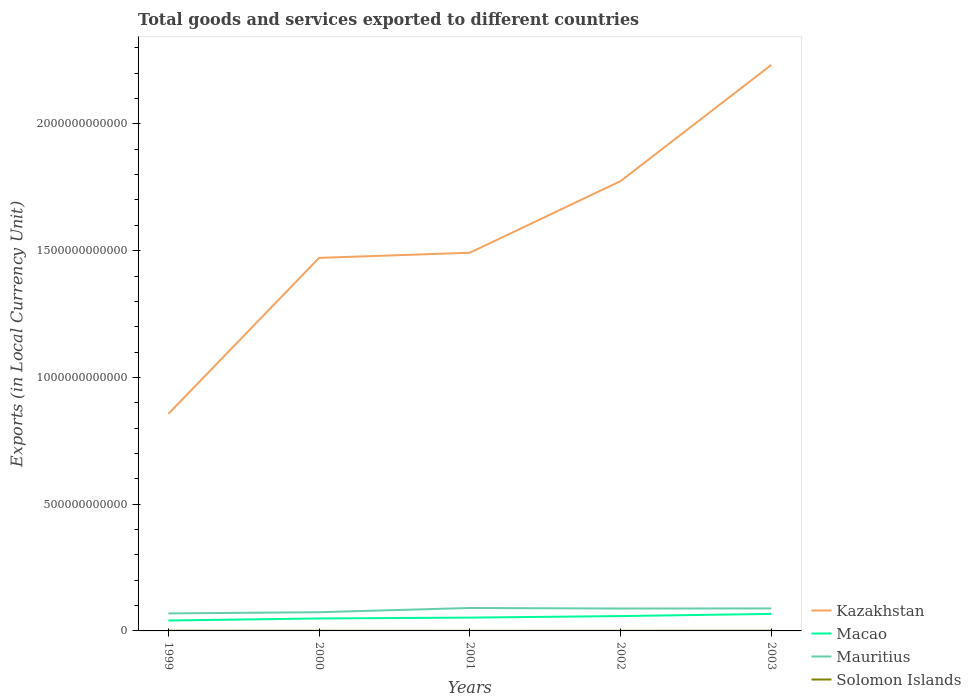How many different coloured lines are there?
Your answer should be compact. 4. Does the line corresponding to Kazakhstan intersect with the line corresponding to Macao?
Keep it short and to the point. No. Across all years, what is the maximum Amount of goods and services exports in Mauritius?
Provide a short and direct response. 6.91e+1. What is the total Amount of goods and services exports in Mauritius in the graph?
Your answer should be compact. -1.66e+1. What is the difference between the highest and the second highest Amount of goods and services exports in Mauritius?
Give a very brief answer. 2.14e+1. Is the Amount of goods and services exports in Kazakhstan strictly greater than the Amount of goods and services exports in Macao over the years?
Provide a succinct answer. No. What is the difference between two consecutive major ticks on the Y-axis?
Your answer should be very brief. 5.00e+11. How many legend labels are there?
Offer a very short reply. 4. How are the legend labels stacked?
Your answer should be very brief. Vertical. What is the title of the graph?
Keep it short and to the point. Total goods and services exported to different countries. Does "French Polynesia" appear as one of the legend labels in the graph?
Your answer should be very brief. No. What is the label or title of the X-axis?
Offer a terse response. Years. What is the label or title of the Y-axis?
Ensure brevity in your answer.  Exports (in Local Currency Unit). What is the Exports (in Local Currency Unit) in Kazakhstan in 1999?
Your answer should be very brief. 8.56e+11. What is the Exports (in Local Currency Unit) in Macao in 1999?
Your response must be concise. 4.11e+1. What is the Exports (in Local Currency Unit) of Mauritius in 1999?
Your answer should be very brief. 6.91e+1. What is the Exports (in Local Currency Unit) in Solomon Islands in 1999?
Give a very brief answer. 8.33e+08. What is the Exports (in Local Currency Unit) in Kazakhstan in 2000?
Offer a terse response. 1.47e+12. What is the Exports (in Local Currency Unit) in Macao in 2000?
Offer a terse response. 4.92e+1. What is the Exports (in Local Currency Unit) in Mauritius in 2000?
Your response must be concise. 7.38e+1. What is the Exports (in Local Currency Unit) in Solomon Islands in 2000?
Make the answer very short. 5.33e+08. What is the Exports (in Local Currency Unit) in Kazakhstan in 2001?
Your answer should be compact. 1.49e+12. What is the Exports (in Local Currency Unit) of Macao in 2001?
Provide a short and direct response. 5.25e+1. What is the Exports (in Local Currency Unit) of Mauritius in 2001?
Give a very brief answer. 9.05e+1. What is the Exports (in Local Currency Unit) in Solomon Islands in 2001?
Make the answer very short. 3.49e+08. What is the Exports (in Local Currency Unit) of Kazakhstan in 2002?
Provide a succinct answer. 1.77e+12. What is the Exports (in Local Currency Unit) in Macao in 2002?
Your response must be concise. 5.86e+1. What is the Exports (in Local Currency Unit) of Mauritius in 2002?
Provide a succinct answer. 8.83e+1. What is the Exports (in Local Currency Unit) of Solomon Islands in 2002?
Provide a short and direct response. 4.63e+08. What is the Exports (in Local Currency Unit) of Kazakhstan in 2003?
Provide a succinct answer. 2.23e+12. What is the Exports (in Local Currency Unit) of Macao in 2003?
Make the answer very short. 6.71e+1. What is the Exports (in Local Currency Unit) of Mauritius in 2003?
Keep it short and to the point. 8.87e+1. What is the Exports (in Local Currency Unit) of Solomon Islands in 2003?
Your response must be concise. 6.60e+08. Across all years, what is the maximum Exports (in Local Currency Unit) in Kazakhstan?
Provide a short and direct response. 2.23e+12. Across all years, what is the maximum Exports (in Local Currency Unit) of Macao?
Give a very brief answer. 6.71e+1. Across all years, what is the maximum Exports (in Local Currency Unit) of Mauritius?
Keep it short and to the point. 9.05e+1. Across all years, what is the maximum Exports (in Local Currency Unit) of Solomon Islands?
Make the answer very short. 8.33e+08. Across all years, what is the minimum Exports (in Local Currency Unit) in Kazakhstan?
Give a very brief answer. 8.56e+11. Across all years, what is the minimum Exports (in Local Currency Unit) in Macao?
Offer a very short reply. 4.11e+1. Across all years, what is the minimum Exports (in Local Currency Unit) in Mauritius?
Keep it short and to the point. 6.91e+1. Across all years, what is the minimum Exports (in Local Currency Unit) of Solomon Islands?
Ensure brevity in your answer.  3.49e+08. What is the total Exports (in Local Currency Unit) in Kazakhstan in the graph?
Provide a succinct answer. 7.83e+12. What is the total Exports (in Local Currency Unit) in Macao in the graph?
Keep it short and to the point. 2.69e+11. What is the total Exports (in Local Currency Unit) in Mauritius in the graph?
Offer a terse response. 4.10e+11. What is the total Exports (in Local Currency Unit) in Solomon Islands in the graph?
Your response must be concise. 2.84e+09. What is the difference between the Exports (in Local Currency Unit) in Kazakhstan in 1999 and that in 2000?
Ensure brevity in your answer.  -6.15e+11. What is the difference between the Exports (in Local Currency Unit) of Macao in 1999 and that in 2000?
Keep it short and to the point. -8.06e+09. What is the difference between the Exports (in Local Currency Unit) of Mauritius in 1999 and that in 2000?
Give a very brief answer. -4.74e+09. What is the difference between the Exports (in Local Currency Unit) of Solomon Islands in 1999 and that in 2000?
Ensure brevity in your answer.  2.99e+08. What is the difference between the Exports (in Local Currency Unit) of Kazakhstan in 1999 and that in 2001?
Offer a terse response. -6.36e+11. What is the difference between the Exports (in Local Currency Unit) in Macao in 1999 and that in 2001?
Give a very brief answer. -1.14e+1. What is the difference between the Exports (in Local Currency Unit) in Mauritius in 1999 and that in 2001?
Your response must be concise. -2.14e+1. What is the difference between the Exports (in Local Currency Unit) in Solomon Islands in 1999 and that in 2001?
Provide a short and direct response. 4.84e+08. What is the difference between the Exports (in Local Currency Unit) of Kazakhstan in 1999 and that in 2002?
Give a very brief answer. -9.18e+11. What is the difference between the Exports (in Local Currency Unit) of Macao in 1999 and that in 2002?
Ensure brevity in your answer.  -1.75e+1. What is the difference between the Exports (in Local Currency Unit) of Mauritius in 1999 and that in 2002?
Provide a short and direct response. -1.92e+1. What is the difference between the Exports (in Local Currency Unit) in Solomon Islands in 1999 and that in 2002?
Your answer should be compact. 3.70e+08. What is the difference between the Exports (in Local Currency Unit) in Kazakhstan in 1999 and that in 2003?
Make the answer very short. -1.38e+12. What is the difference between the Exports (in Local Currency Unit) in Macao in 1999 and that in 2003?
Ensure brevity in your answer.  -2.60e+1. What is the difference between the Exports (in Local Currency Unit) in Mauritius in 1999 and that in 2003?
Provide a succinct answer. -1.96e+1. What is the difference between the Exports (in Local Currency Unit) of Solomon Islands in 1999 and that in 2003?
Give a very brief answer. 1.73e+08. What is the difference between the Exports (in Local Currency Unit) in Kazakhstan in 2000 and that in 2001?
Give a very brief answer. -2.03e+1. What is the difference between the Exports (in Local Currency Unit) of Macao in 2000 and that in 2001?
Offer a very short reply. -3.31e+09. What is the difference between the Exports (in Local Currency Unit) of Mauritius in 2000 and that in 2001?
Your answer should be very brief. -1.66e+1. What is the difference between the Exports (in Local Currency Unit) in Solomon Islands in 2000 and that in 2001?
Make the answer very short. 1.84e+08. What is the difference between the Exports (in Local Currency Unit) in Kazakhstan in 2000 and that in 2002?
Your response must be concise. -3.03e+11. What is the difference between the Exports (in Local Currency Unit) in Macao in 2000 and that in 2002?
Give a very brief answer. -9.45e+09. What is the difference between the Exports (in Local Currency Unit) in Mauritius in 2000 and that in 2002?
Ensure brevity in your answer.  -1.45e+1. What is the difference between the Exports (in Local Currency Unit) in Solomon Islands in 2000 and that in 2002?
Keep it short and to the point. 7.07e+07. What is the difference between the Exports (in Local Currency Unit) of Kazakhstan in 2000 and that in 2003?
Offer a very short reply. -7.61e+11. What is the difference between the Exports (in Local Currency Unit) of Macao in 2000 and that in 2003?
Ensure brevity in your answer.  -1.79e+1. What is the difference between the Exports (in Local Currency Unit) of Mauritius in 2000 and that in 2003?
Make the answer very short. -1.49e+1. What is the difference between the Exports (in Local Currency Unit) of Solomon Islands in 2000 and that in 2003?
Make the answer very short. -1.26e+08. What is the difference between the Exports (in Local Currency Unit) of Kazakhstan in 2001 and that in 2002?
Offer a terse response. -2.83e+11. What is the difference between the Exports (in Local Currency Unit) of Macao in 2001 and that in 2002?
Offer a very short reply. -6.15e+09. What is the difference between the Exports (in Local Currency Unit) of Mauritius in 2001 and that in 2002?
Keep it short and to the point. 2.16e+09. What is the difference between the Exports (in Local Currency Unit) in Solomon Islands in 2001 and that in 2002?
Make the answer very short. -1.14e+08. What is the difference between the Exports (in Local Currency Unit) in Kazakhstan in 2001 and that in 2003?
Your answer should be compact. -7.41e+11. What is the difference between the Exports (in Local Currency Unit) of Macao in 2001 and that in 2003?
Offer a very short reply. -1.46e+1. What is the difference between the Exports (in Local Currency Unit) in Mauritius in 2001 and that in 2003?
Your answer should be compact. 1.75e+09. What is the difference between the Exports (in Local Currency Unit) in Solomon Islands in 2001 and that in 2003?
Offer a terse response. -3.10e+08. What is the difference between the Exports (in Local Currency Unit) in Kazakhstan in 2002 and that in 2003?
Your answer should be compact. -4.58e+11. What is the difference between the Exports (in Local Currency Unit) of Macao in 2002 and that in 2003?
Offer a terse response. -8.47e+09. What is the difference between the Exports (in Local Currency Unit) of Mauritius in 2002 and that in 2003?
Your answer should be very brief. -4.13e+08. What is the difference between the Exports (in Local Currency Unit) in Solomon Islands in 2002 and that in 2003?
Your response must be concise. -1.97e+08. What is the difference between the Exports (in Local Currency Unit) of Kazakhstan in 1999 and the Exports (in Local Currency Unit) of Macao in 2000?
Provide a short and direct response. 8.07e+11. What is the difference between the Exports (in Local Currency Unit) of Kazakhstan in 1999 and the Exports (in Local Currency Unit) of Mauritius in 2000?
Provide a succinct answer. 7.82e+11. What is the difference between the Exports (in Local Currency Unit) of Kazakhstan in 1999 and the Exports (in Local Currency Unit) of Solomon Islands in 2000?
Your answer should be very brief. 8.56e+11. What is the difference between the Exports (in Local Currency Unit) of Macao in 1999 and the Exports (in Local Currency Unit) of Mauritius in 2000?
Offer a terse response. -3.27e+1. What is the difference between the Exports (in Local Currency Unit) in Macao in 1999 and the Exports (in Local Currency Unit) in Solomon Islands in 2000?
Your answer should be very brief. 4.06e+1. What is the difference between the Exports (in Local Currency Unit) in Mauritius in 1999 and the Exports (in Local Currency Unit) in Solomon Islands in 2000?
Your response must be concise. 6.86e+1. What is the difference between the Exports (in Local Currency Unit) in Kazakhstan in 1999 and the Exports (in Local Currency Unit) in Macao in 2001?
Your answer should be very brief. 8.04e+11. What is the difference between the Exports (in Local Currency Unit) of Kazakhstan in 1999 and the Exports (in Local Currency Unit) of Mauritius in 2001?
Your answer should be very brief. 7.66e+11. What is the difference between the Exports (in Local Currency Unit) of Kazakhstan in 1999 and the Exports (in Local Currency Unit) of Solomon Islands in 2001?
Provide a succinct answer. 8.56e+11. What is the difference between the Exports (in Local Currency Unit) of Macao in 1999 and the Exports (in Local Currency Unit) of Mauritius in 2001?
Offer a terse response. -4.93e+1. What is the difference between the Exports (in Local Currency Unit) in Macao in 1999 and the Exports (in Local Currency Unit) in Solomon Islands in 2001?
Your answer should be compact. 4.08e+1. What is the difference between the Exports (in Local Currency Unit) of Mauritius in 1999 and the Exports (in Local Currency Unit) of Solomon Islands in 2001?
Give a very brief answer. 6.88e+1. What is the difference between the Exports (in Local Currency Unit) of Kazakhstan in 1999 and the Exports (in Local Currency Unit) of Macao in 2002?
Give a very brief answer. 7.98e+11. What is the difference between the Exports (in Local Currency Unit) in Kazakhstan in 1999 and the Exports (in Local Currency Unit) in Mauritius in 2002?
Your answer should be very brief. 7.68e+11. What is the difference between the Exports (in Local Currency Unit) in Kazakhstan in 1999 and the Exports (in Local Currency Unit) in Solomon Islands in 2002?
Provide a succinct answer. 8.56e+11. What is the difference between the Exports (in Local Currency Unit) in Macao in 1999 and the Exports (in Local Currency Unit) in Mauritius in 2002?
Offer a terse response. -4.72e+1. What is the difference between the Exports (in Local Currency Unit) of Macao in 1999 and the Exports (in Local Currency Unit) of Solomon Islands in 2002?
Your response must be concise. 4.07e+1. What is the difference between the Exports (in Local Currency Unit) of Mauritius in 1999 and the Exports (in Local Currency Unit) of Solomon Islands in 2002?
Keep it short and to the point. 6.86e+1. What is the difference between the Exports (in Local Currency Unit) in Kazakhstan in 1999 and the Exports (in Local Currency Unit) in Macao in 2003?
Give a very brief answer. 7.89e+11. What is the difference between the Exports (in Local Currency Unit) of Kazakhstan in 1999 and the Exports (in Local Currency Unit) of Mauritius in 2003?
Make the answer very short. 7.68e+11. What is the difference between the Exports (in Local Currency Unit) of Kazakhstan in 1999 and the Exports (in Local Currency Unit) of Solomon Islands in 2003?
Keep it short and to the point. 8.56e+11. What is the difference between the Exports (in Local Currency Unit) of Macao in 1999 and the Exports (in Local Currency Unit) of Mauritius in 2003?
Provide a short and direct response. -4.76e+1. What is the difference between the Exports (in Local Currency Unit) in Macao in 1999 and the Exports (in Local Currency Unit) in Solomon Islands in 2003?
Provide a short and direct response. 4.05e+1. What is the difference between the Exports (in Local Currency Unit) of Mauritius in 1999 and the Exports (in Local Currency Unit) of Solomon Islands in 2003?
Make the answer very short. 6.84e+1. What is the difference between the Exports (in Local Currency Unit) in Kazakhstan in 2000 and the Exports (in Local Currency Unit) in Macao in 2001?
Offer a terse response. 1.42e+12. What is the difference between the Exports (in Local Currency Unit) in Kazakhstan in 2000 and the Exports (in Local Currency Unit) in Mauritius in 2001?
Make the answer very short. 1.38e+12. What is the difference between the Exports (in Local Currency Unit) of Kazakhstan in 2000 and the Exports (in Local Currency Unit) of Solomon Islands in 2001?
Provide a short and direct response. 1.47e+12. What is the difference between the Exports (in Local Currency Unit) in Macao in 2000 and the Exports (in Local Currency Unit) in Mauritius in 2001?
Provide a succinct answer. -4.13e+1. What is the difference between the Exports (in Local Currency Unit) in Macao in 2000 and the Exports (in Local Currency Unit) in Solomon Islands in 2001?
Make the answer very short. 4.88e+1. What is the difference between the Exports (in Local Currency Unit) of Mauritius in 2000 and the Exports (in Local Currency Unit) of Solomon Islands in 2001?
Offer a terse response. 7.35e+1. What is the difference between the Exports (in Local Currency Unit) of Kazakhstan in 2000 and the Exports (in Local Currency Unit) of Macao in 2002?
Keep it short and to the point. 1.41e+12. What is the difference between the Exports (in Local Currency Unit) in Kazakhstan in 2000 and the Exports (in Local Currency Unit) in Mauritius in 2002?
Your answer should be compact. 1.38e+12. What is the difference between the Exports (in Local Currency Unit) of Kazakhstan in 2000 and the Exports (in Local Currency Unit) of Solomon Islands in 2002?
Your answer should be very brief. 1.47e+12. What is the difference between the Exports (in Local Currency Unit) in Macao in 2000 and the Exports (in Local Currency Unit) in Mauritius in 2002?
Ensure brevity in your answer.  -3.91e+1. What is the difference between the Exports (in Local Currency Unit) of Macao in 2000 and the Exports (in Local Currency Unit) of Solomon Islands in 2002?
Keep it short and to the point. 4.87e+1. What is the difference between the Exports (in Local Currency Unit) of Mauritius in 2000 and the Exports (in Local Currency Unit) of Solomon Islands in 2002?
Ensure brevity in your answer.  7.34e+1. What is the difference between the Exports (in Local Currency Unit) in Kazakhstan in 2000 and the Exports (in Local Currency Unit) in Macao in 2003?
Provide a short and direct response. 1.40e+12. What is the difference between the Exports (in Local Currency Unit) of Kazakhstan in 2000 and the Exports (in Local Currency Unit) of Mauritius in 2003?
Offer a terse response. 1.38e+12. What is the difference between the Exports (in Local Currency Unit) of Kazakhstan in 2000 and the Exports (in Local Currency Unit) of Solomon Islands in 2003?
Your answer should be compact. 1.47e+12. What is the difference between the Exports (in Local Currency Unit) in Macao in 2000 and the Exports (in Local Currency Unit) in Mauritius in 2003?
Your response must be concise. -3.95e+1. What is the difference between the Exports (in Local Currency Unit) in Macao in 2000 and the Exports (in Local Currency Unit) in Solomon Islands in 2003?
Make the answer very short. 4.85e+1. What is the difference between the Exports (in Local Currency Unit) of Mauritius in 2000 and the Exports (in Local Currency Unit) of Solomon Islands in 2003?
Offer a terse response. 7.32e+1. What is the difference between the Exports (in Local Currency Unit) in Kazakhstan in 2001 and the Exports (in Local Currency Unit) in Macao in 2002?
Give a very brief answer. 1.43e+12. What is the difference between the Exports (in Local Currency Unit) in Kazakhstan in 2001 and the Exports (in Local Currency Unit) in Mauritius in 2002?
Offer a terse response. 1.40e+12. What is the difference between the Exports (in Local Currency Unit) of Kazakhstan in 2001 and the Exports (in Local Currency Unit) of Solomon Islands in 2002?
Your answer should be very brief. 1.49e+12. What is the difference between the Exports (in Local Currency Unit) in Macao in 2001 and the Exports (in Local Currency Unit) in Mauritius in 2002?
Your answer should be compact. -3.58e+1. What is the difference between the Exports (in Local Currency Unit) of Macao in 2001 and the Exports (in Local Currency Unit) of Solomon Islands in 2002?
Ensure brevity in your answer.  5.20e+1. What is the difference between the Exports (in Local Currency Unit) in Mauritius in 2001 and the Exports (in Local Currency Unit) in Solomon Islands in 2002?
Your response must be concise. 9.00e+1. What is the difference between the Exports (in Local Currency Unit) in Kazakhstan in 2001 and the Exports (in Local Currency Unit) in Macao in 2003?
Offer a terse response. 1.42e+12. What is the difference between the Exports (in Local Currency Unit) in Kazakhstan in 2001 and the Exports (in Local Currency Unit) in Mauritius in 2003?
Keep it short and to the point. 1.40e+12. What is the difference between the Exports (in Local Currency Unit) in Kazakhstan in 2001 and the Exports (in Local Currency Unit) in Solomon Islands in 2003?
Provide a succinct answer. 1.49e+12. What is the difference between the Exports (in Local Currency Unit) of Macao in 2001 and the Exports (in Local Currency Unit) of Mauritius in 2003?
Offer a terse response. -3.62e+1. What is the difference between the Exports (in Local Currency Unit) in Macao in 2001 and the Exports (in Local Currency Unit) in Solomon Islands in 2003?
Your answer should be compact. 5.18e+1. What is the difference between the Exports (in Local Currency Unit) of Mauritius in 2001 and the Exports (in Local Currency Unit) of Solomon Islands in 2003?
Your answer should be very brief. 8.98e+1. What is the difference between the Exports (in Local Currency Unit) of Kazakhstan in 2002 and the Exports (in Local Currency Unit) of Macao in 2003?
Ensure brevity in your answer.  1.71e+12. What is the difference between the Exports (in Local Currency Unit) in Kazakhstan in 2002 and the Exports (in Local Currency Unit) in Mauritius in 2003?
Provide a succinct answer. 1.69e+12. What is the difference between the Exports (in Local Currency Unit) of Kazakhstan in 2002 and the Exports (in Local Currency Unit) of Solomon Islands in 2003?
Keep it short and to the point. 1.77e+12. What is the difference between the Exports (in Local Currency Unit) of Macao in 2002 and the Exports (in Local Currency Unit) of Mauritius in 2003?
Ensure brevity in your answer.  -3.01e+1. What is the difference between the Exports (in Local Currency Unit) in Macao in 2002 and the Exports (in Local Currency Unit) in Solomon Islands in 2003?
Keep it short and to the point. 5.80e+1. What is the difference between the Exports (in Local Currency Unit) in Mauritius in 2002 and the Exports (in Local Currency Unit) in Solomon Islands in 2003?
Offer a terse response. 8.76e+1. What is the average Exports (in Local Currency Unit) of Kazakhstan per year?
Make the answer very short. 1.57e+12. What is the average Exports (in Local Currency Unit) in Macao per year?
Offer a terse response. 5.37e+1. What is the average Exports (in Local Currency Unit) of Mauritius per year?
Give a very brief answer. 8.21e+1. What is the average Exports (in Local Currency Unit) in Solomon Islands per year?
Ensure brevity in your answer.  5.67e+08. In the year 1999, what is the difference between the Exports (in Local Currency Unit) in Kazakhstan and Exports (in Local Currency Unit) in Macao?
Offer a very short reply. 8.15e+11. In the year 1999, what is the difference between the Exports (in Local Currency Unit) in Kazakhstan and Exports (in Local Currency Unit) in Mauritius?
Keep it short and to the point. 7.87e+11. In the year 1999, what is the difference between the Exports (in Local Currency Unit) of Kazakhstan and Exports (in Local Currency Unit) of Solomon Islands?
Give a very brief answer. 8.55e+11. In the year 1999, what is the difference between the Exports (in Local Currency Unit) in Macao and Exports (in Local Currency Unit) in Mauritius?
Provide a short and direct response. -2.80e+1. In the year 1999, what is the difference between the Exports (in Local Currency Unit) in Macao and Exports (in Local Currency Unit) in Solomon Islands?
Your response must be concise. 4.03e+1. In the year 1999, what is the difference between the Exports (in Local Currency Unit) of Mauritius and Exports (in Local Currency Unit) of Solomon Islands?
Provide a short and direct response. 6.83e+1. In the year 2000, what is the difference between the Exports (in Local Currency Unit) in Kazakhstan and Exports (in Local Currency Unit) in Macao?
Ensure brevity in your answer.  1.42e+12. In the year 2000, what is the difference between the Exports (in Local Currency Unit) of Kazakhstan and Exports (in Local Currency Unit) of Mauritius?
Offer a very short reply. 1.40e+12. In the year 2000, what is the difference between the Exports (in Local Currency Unit) of Kazakhstan and Exports (in Local Currency Unit) of Solomon Islands?
Keep it short and to the point. 1.47e+12. In the year 2000, what is the difference between the Exports (in Local Currency Unit) of Macao and Exports (in Local Currency Unit) of Mauritius?
Offer a very short reply. -2.47e+1. In the year 2000, what is the difference between the Exports (in Local Currency Unit) of Macao and Exports (in Local Currency Unit) of Solomon Islands?
Provide a succinct answer. 4.86e+1. In the year 2000, what is the difference between the Exports (in Local Currency Unit) in Mauritius and Exports (in Local Currency Unit) in Solomon Islands?
Keep it short and to the point. 7.33e+1. In the year 2001, what is the difference between the Exports (in Local Currency Unit) of Kazakhstan and Exports (in Local Currency Unit) of Macao?
Give a very brief answer. 1.44e+12. In the year 2001, what is the difference between the Exports (in Local Currency Unit) in Kazakhstan and Exports (in Local Currency Unit) in Mauritius?
Ensure brevity in your answer.  1.40e+12. In the year 2001, what is the difference between the Exports (in Local Currency Unit) in Kazakhstan and Exports (in Local Currency Unit) in Solomon Islands?
Make the answer very short. 1.49e+12. In the year 2001, what is the difference between the Exports (in Local Currency Unit) in Macao and Exports (in Local Currency Unit) in Mauritius?
Offer a very short reply. -3.80e+1. In the year 2001, what is the difference between the Exports (in Local Currency Unit) in Macao and Exports (in Local Currency Unit) in Solomon Islands?
Your response must be concise. 5.21e+1. In the year 2001, what is the difference between the Exports (in Local Currency Unit) of Mauritius and Exports (in Local Currency Unit) of Solomon Islands?
Keep it short and to the point. 9.01e+1. In the year 2002, what is the difference between the Exports (in Local Currency Unit) of Kazakhstan and Exports (in Local Currency Unit) of Macao?
Ensure brevity in your answer.  1.72e+12. In the year 2002, what is the difference between the Exports (in Local Currency Unit) of Kazakhstan and Exports (in Local Currency Unit) of Mauritius?
Your answer should be compact. 1.69e+12. In the year 2002, what is the difference between the Exports (in Local Currency Unit) in Kazakhstan and Exports (in Local Currency Unit) in Solomon Islands?
Provide a succinct answer. 1.77e+12. In the year 2002, what is the difference between the Exports (in Local Currency Unit) of Macao and Exports (in Local Currency Unit) of Mauritius?
Provide a succinct answer. -2.97e+1. In the year 2002, what is the difference between the Exports (in Local Currency Unit) in Macao and Exports (in Local Currency Unit) in Solomon Islands?
Ensure brevity in your answer.  5.82e+1. In the year 2002, what is the difference between the Exports (in Local Currency Unit) in Mauritius and Exports (in Local Currency Unit) in Solomon Islands?
Make the answer very short. 8.78e+1. In the year 2003, what is the difference between the Exports (in Local Currency Unit) in Kazakhstan and Exports (in Local Currency Unit) in Macao?
Make the answer very short. 2.17e+12. In the year 2003, what is the difference between the Exports (in Local Currency Unit) of Kazakhstan and Exports (in Local Currency Unit) of Mauritius?
Ensure brevity in your answer.  2.14e+12. In the year 2003, what is the difference between the Exports (in Local Currency Unit) of Kazakhstan and Exports (in Local Currency Unit) of Solomon Islands?
Offer a very short reply. 2.23e+12. In the year 2003, what is the difference between the Exports (in Local Currency Unit) in Macao and Exports (in Local Currency Unit) in Mauritius?
Give a very brief answer. -2.16e+1. In the year 2003, what is the difference between the Exports (in Local Currency Unit) in Macao and Exports (in Local Currency Unit) in Solomon Islands?
Give a very brief answer. 6.64e+1. In the year 2003, what is the difference between the Exports (in Local Currency Unit) in Mauritius and Exports (in Local Currency Unit) in Solomon Islands?
Give a very brief answer. 8.81e+1. What is the ratio of the Exports (in Local Currency Unit) of Kazakhstan in 1999 to that in 2000?
Your answer should be very brief. 0.58. What is the ratio of the Exports (in Local Currency Unit) in Macao in 1999 to that in 2000?
Offer a terse response. 0.84. What is the ratio of the Exports (in Local Currency Unit) in Mauritius in 1999 to that in 2000?
Your response must be concise. 0.94. What is the ratio of the Exports (in Local Currency Unit) of Solomon Islands in 1999 to that in 2000?
Keep it short and to the point. 1.56. What is the ratio of the Exports (in Local Currency Unit) in Kazakhstan in 1999 to that in 2001?
Give a very brief answer. 0.57. What is the ratio of the Exports (in Local Currency Unit) in Macao in 1999 to that in 2001?
Make the answer very short. 0.78. What is the ratio of the Exports (in Local Currency Unit) of Mauritius in 1999 to that in 2001?
Your response must be concise. 0.76. What is the ratio of the Exports (in Local Currency Unit) of Solomon Islands in 1999 to that in 2001?
Make the answer very short. 2.39. What is the ratio of the Exports (in Local Currency Unit) of Kazakhstan in 1999 to that in 2002?
Make the answer very short. 0.48. What is the ratio of the Exports (in Local Currency Unit) of Macao in 1999 to that in 2002?
Offer a very short reply. 0.7. What is the ratio of the Exports (in Local Currency Unit) in Mauritius in 1999 to that in 2002?
Your response must be concise. 0.78. What is the ratio of the Exports (in Local Currency Unit) of Solomon Islands in 1999 to that in 2002?
Give a very brief answer. 1.8. What is the ratio of the Exports (in Local Currency Unit) of Kazakhstan in 1999 to that in 2003?
Provide a succinct answer. 0.38. What is the ratio of the Exports (in Local Currency Unit) in Macao in 1999 to that in 2003?
Offer a very short reply. 0.61. What is the ratio of the Exports (in Local Currency Unit) in Mauritius in 1999 to that in 2003?
Make the answer very short. 0.78. What is the ratio of the Exports (in Local Currency Unit) of Solomon Islands in 1999 to that in 2003?
Your answer should be compact. 1.26. What is the ratio of the Exports (in Local Currency Unit) of Kazakhstan in 2000 to that in 2001?
Provide a succinct answer. 0.99. What is the ratio of the Exports (in Local Currency Unit) of Macao in 2000 to that in 2001?
Provide a short and direct response. 0.94. What is the ratio of the Exports (in Local Currency Unit) in Mauritius in 2000 to that in 2001?
Provide a short and direct response. 0.82. What is the ratio of the Exports (in Local Currency Unit) of Solomon Islands in 2000 to that in 2001?
Ensure brevity in your answer.  1.53. What is the ratio of the Exports (in Local Currency Unit) in Kazakhstan in 2000 to that in 2002?
Offer a very short reply. 0.83. What is the ratio of the Exports (in Local Currency Unit) of Macao in 2000 to that in 2002?
Keep it short and to the point. 0.84. What is the ratio of the Exports (in Local Currency Unit) of Mauritius in 2000 to that in 2002?
Ensure brevity in your answer.  0.84. What is the ratio of the Exports (in Local Currency Unit) of Solomon Islands in 2000 to that in 2002?
Offer a terse response. 1.15. What is the ratio of the Exports (in Local Currency Unit) in Kazakhstan in 2000 to that in 2003?
Make the answer very short. 0.66. What is the ratio of the Exports (in Local Currency Unit) of Macao in 2000 to that in 2003?
Provide a short and direct response. 0.73. What is the ratio of the Exports (in Local Currency Unit) in Mauritius in 2000 to that in 2003?
Make the answer very short. 0.83. What is the ratio of the Exports (in Local Currency Unit) of Solomon Islands in 2000 to that in 2003?
Keep it short and to the point. 0.81. What is the ratio of the Exports (in Local Currency Unit) of Kazakhstan in 2001 to that in 2002?
Your response must be concise. 0.84. What is the ratio of the Exports (in Local Currency Unit) of Macao in 2001 to that in 2002?
Offer a terse response. 0.9. What is the ratio of the Exports (in Local Currency Unit) in Mauritius in 2001 to that in 2002?
Provide a succinct answer. 1.02. What is the ratio of the Exports (in Local Currency Unit) in Solomon Islands in 2001 to that in 2002?
Ensure brevity in your answer.  0.75. What is the ratio of the Exports (in Local Currency Unit) of Kazakhstan in 2001 to that in 2003?
Your answer should be compact. 0.67. What is the ratio of the Exports (in Local Currency Unit) in Macao in 2001 to that in 2003?
Offer a terse response. 0.78. What is the ratio of the Exports (in Local Currency Unit) in Mauritius in 2001 to that in 2003?
Offer a terse response. 1.02. What is the ratio of the Exports (in Local Currency Unit) in Solomon Islands in 2001 to that in 2003?
Keep it short and to the point. 0.53. What is the ratio of the Exports (in Local Currency Unit) in Kazakhstan in 2002 to that in 2003?
Keep it short and to the point. 0.79. What is the ratio of the Exports (in Local Currency Unit) in Macao in 2002 to that in 2003?
Keep it short and to the point. 0.87. What is the ratio of the Exports (in Local Currency Unit) of Mauritius in 2002 to that in 2003?
Provide a short and direct response. 1. What is the ratio of the Exports (in Local Currency Unit) of Solomon Islands in 2002 to that in 2003?
Give a very brief answer. 0.7. What is the difference between the highest and the second highest Exports (in Local Currency Unit) of Kazakhstan?
Provide a short and direct response. 4.58e+11. What is the difference between the highest and the second highest Exports (in Local Currency Unit) of Macao?
Provide a succinct answer. 8.47e+09. What is the difference between the highest and the second highest Exports (in Local Currency Unit) of Mauritius?
Offer a terse response. 1.75e+09. What is the difference between the highest and the second highest Exports (in Local Currency Unit) of Solomon Islands?
Your answer should be compact. 1.73e+08. What is the difference between the highest and the lowest Exports (in Local Currency Unit) in Kazakhstan?
Give a very brief answer. 1.38e+12. What is the difference between the highest and the lowest Exports (in Local Currency Unit) of Macao?
Your answer should be very brief. 2.60e+1. What is the difference between the highest and the lowest Exports (in Local Currency Unit) in Mauritius?
Your answer should be compact. 2.14e+1. What is the difference between the highest and the lowest Exports (in Local Currency Unit) of Solomon Islands?
Your response must be concise. 4.84e+08. 